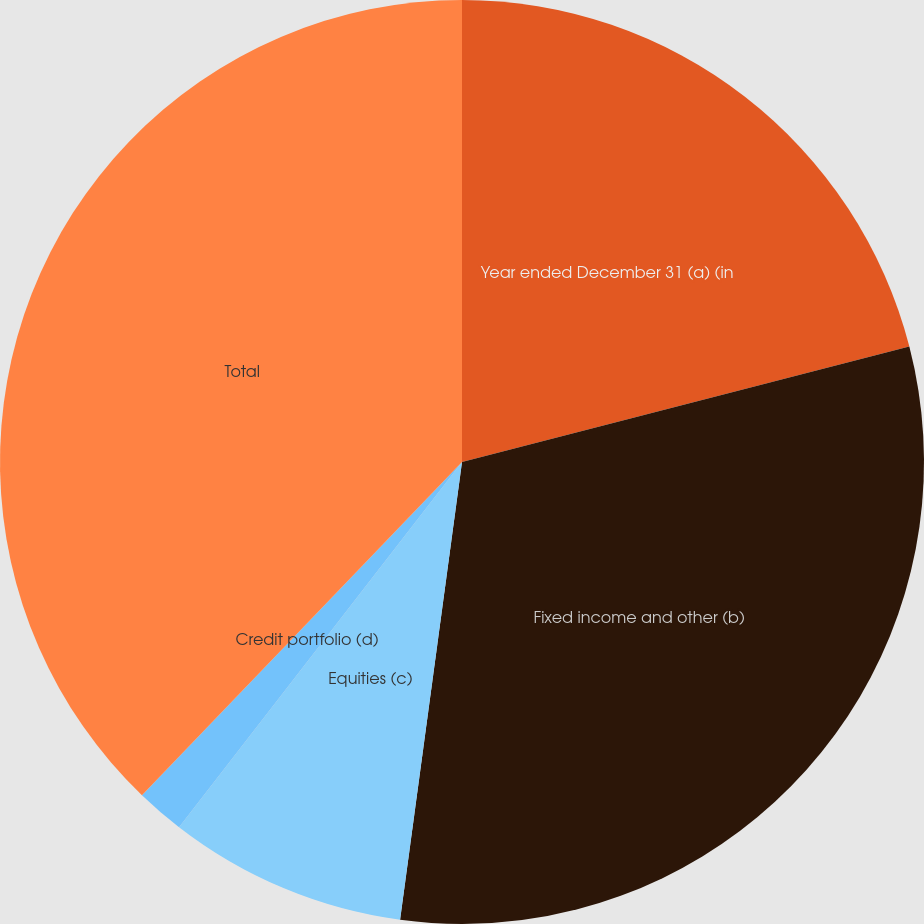<chart> <loc_0><loc_0><loc_500><loc_500><pie_chart><fcel>Year ended December 31 (a) (in<fcel>Fixed income and other (b)<fcel>Equities (c)<fcel>Credit portfolio (d)<fcel>Total<nl><fcel>20.98%<fcel>31.16%<fcel>8.35%<fcel>1.69%<fcel>37.82%<nl></chart> 